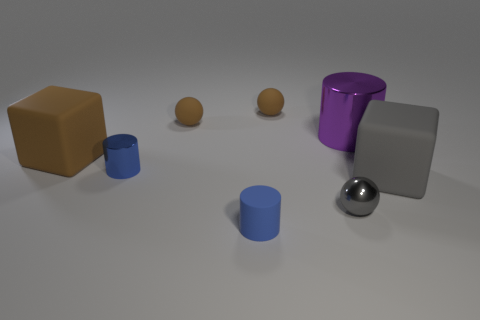Subtract all blue shiny cylinders. How many cylinders are left? 2 Add 1 small yellow matte cubes. How many objects exist? 9 Subtract all balls. How many objects are left? 5 Subtract 2 cylinders. How many cylinders are left? 1 Add 7 spheres. How many spheres are left? 10 Add 7 gray things. How many gray things exist? 9 Subtract all purple cylinders. How many cylinders are left? 2 Subtract 0 yellow cylinders. How many objects are left? 8 Subtract all red cylinders. Subtract all purple blocks. How many cylinders are left? 3 Subtract all green balls. How many yellow cubes are left? 0 